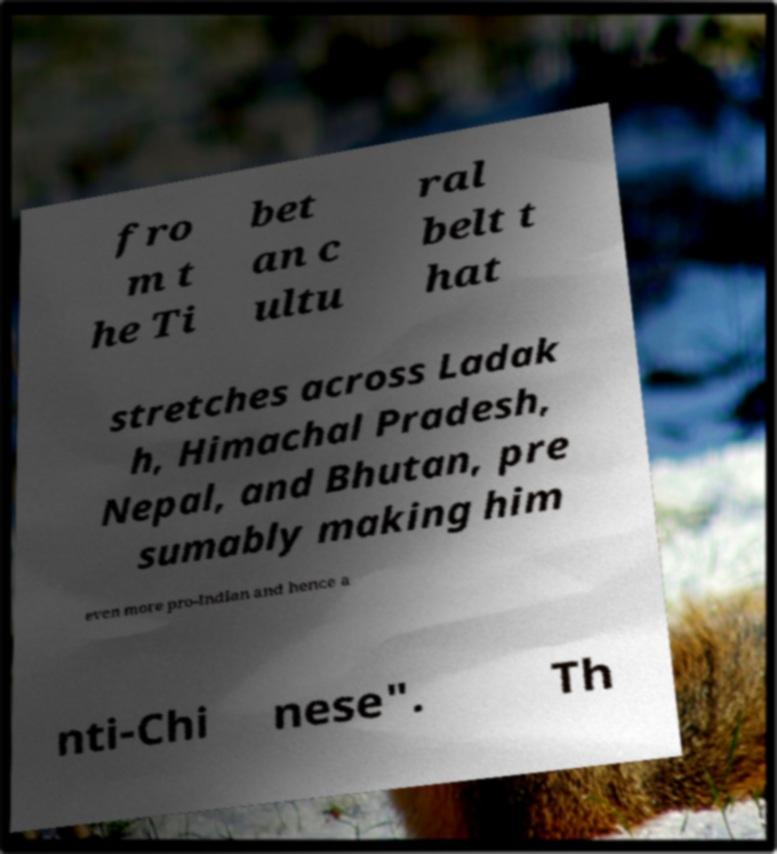Please read and relay the text visible in this image. What does it say? fro m t he Ti bet an c ultu ral belt t hat stretches across Ladak h, Himachal Pradesh, Nepal, and Bhutan, pre sumably making him even more pro-Indian and hence a nti-Chi nese". Th 